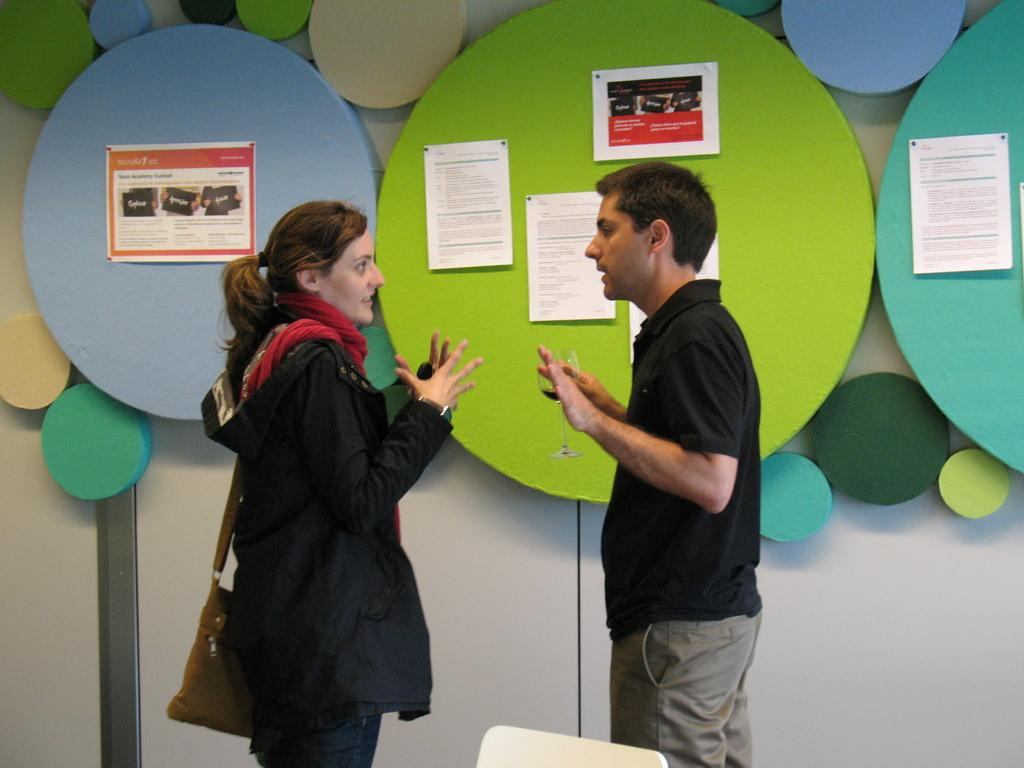What are the two people in the image doing? The two people in the image are standing and talking. Can you describe what one of the people is holding? One person is holding a glass. What is the other person carrying? The other person is carrying a bag. What can be seen in the background of the image? There are colorful borders and posters on boards in the background. Where can a giraffe be seen in the image? There is no giraffe present in the image. What type of agreement are the two people discussing in the image? The image does not provide any information about an agreement being discussed. 